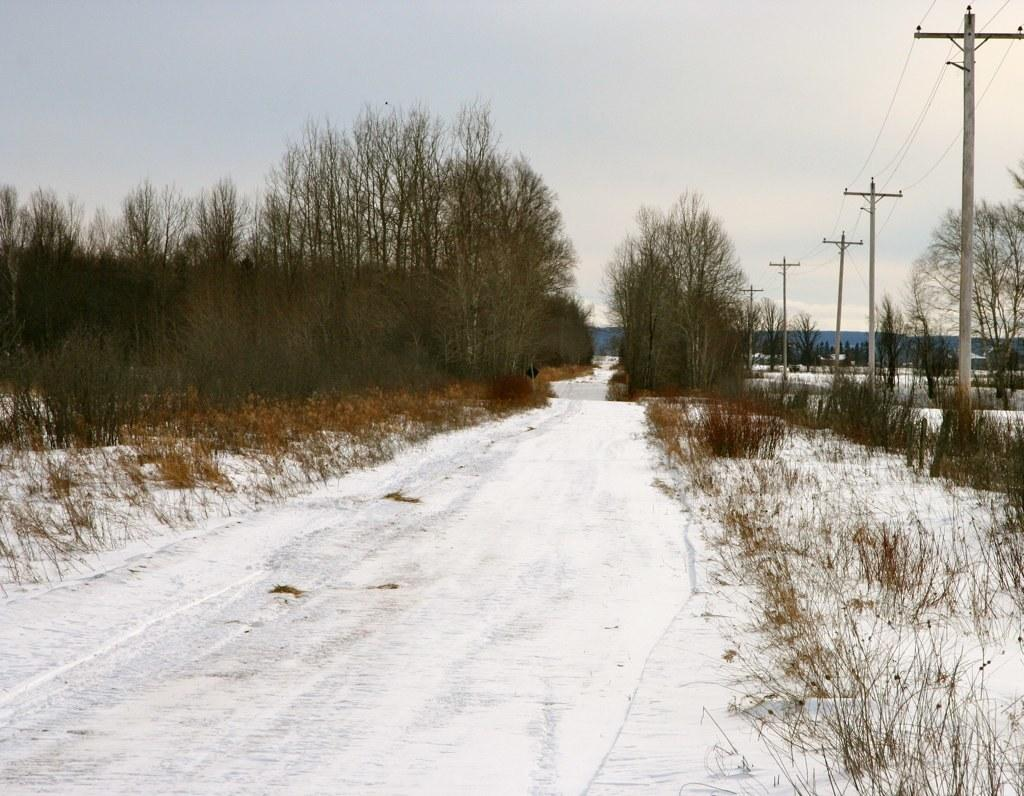What is the predominant color of the snow in the image? The snow in the image is white. What can be seen in the background of the image? There are trees in the background of the image, which are green. What structures are visible in the image? Electric poles are visible in the image. What is the color of the sky in the image? The sky is white in the image. What type of tomatoes can be seen growing on the electric poles in the image? There are no tomatoes present in the image, and tomatoes do not grow on electric poles. 